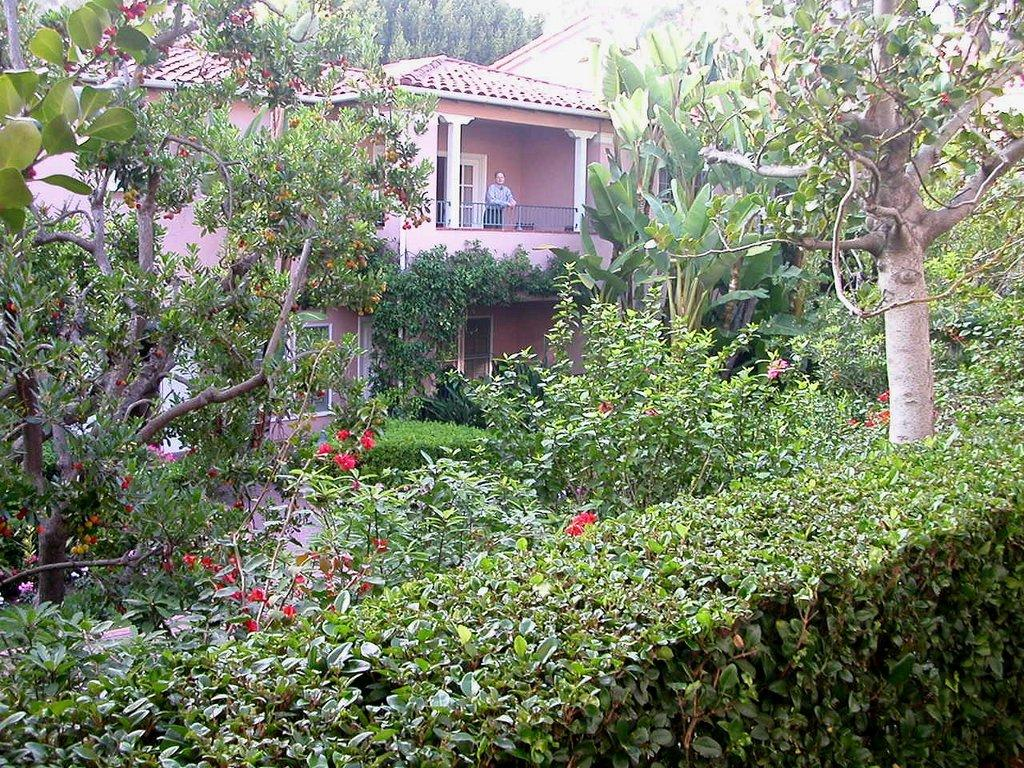What type of plants can be seen in the image? There are plants, flower plants, and trees in the image. What type of structure is present in the image? There is a house in the image. Who or what is present in the image besides the plants and house? There is a person standing in the image. What type of barrier is visible in the image? There is a metal grill fence in the image. What type of stew is being cooked by the person in the image? There is no indication in the image that a person is cooking or that there is any stew present. 